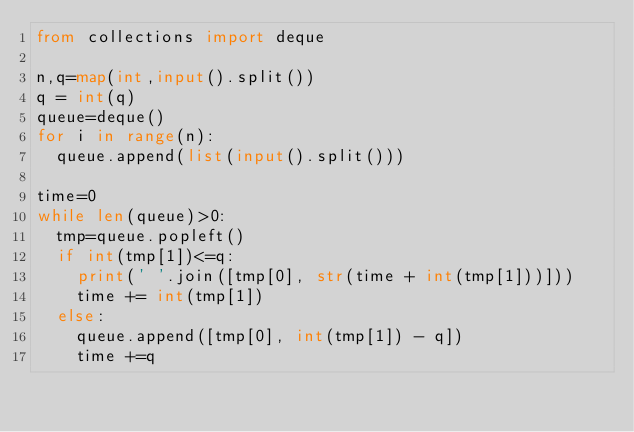Convert code to text. <code><loc_0><loc_0><loc_500><loc_500><_Python_>from collections import deque

n,q=map(int,input().split())
q = int(q)
queue=deque()
for i in range(n):
  queue.append(list(input().split()))

time=0
while len(queue)>0:
  tmp=queue.popleft()
  if int(tmp[1])<=q:
    print(' '.join([tmp[0], str(time + int(tmp[1]))]))
    time += int(tmp[1])
  else:
    queue.append([tmp[0], int(tmp[1]) - q])
    time +=q
</code> 